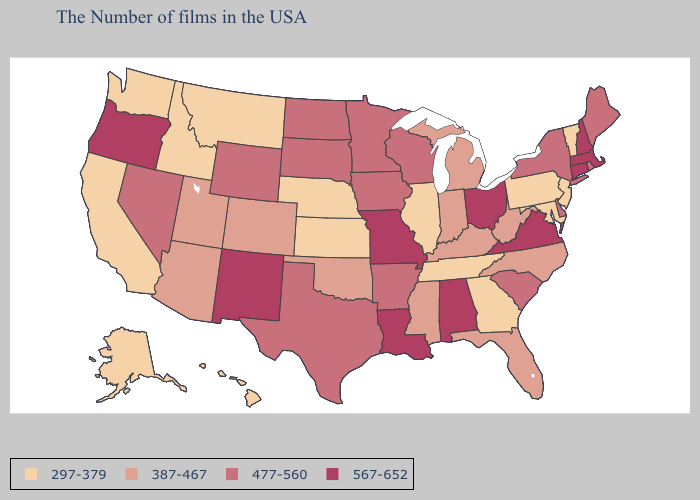Does the map have missing data?
Keep it brief. No. Does Connecticut have the highest value in the Northeast?
Be succinct. Yes. What is the value of Minnesota?
Quick response, please. 477-560. What is the value of Rhode Island?
Keep it brief. 477-560. Name the states that have a value in the range 567-652?
Answer briefly. Massachusetts, New Hampshire, Connecticut, Virginia, Ohio, Alabama, Louisiana, Missouri, New Mexico, Oregon. What is the lowest value in the MidWest?
Keep it brief. 297-379. What is the value of North Dakota?
Answer briefly. 477-560. What is the value of Utah?
Write a very short answer. 387-467. What is the value of Michigan?
Keep it brief. 387-467. Is the legend a continuous bar?
Short answer required. No. How many symbols are there in the legend?
Be succinct. 4. Does Missouri have the same value as New Mexico?
Quick response, please. Yes. Does the first symbol in the legend represent the smallest category?
Keep it brief. Yes. Name the states that have a value in the range 477-560?
Quick response, please. Maine, Rhode Island, New York, Delaware, South Carolina, Wisconsin, Arkansas, Minnesota, Iowa, Texas, South Dakota, North Dakota, Wyoming, Nevada. Does Rhode Island have the lowest value in the Northeast?
Write a very short answer. No. 